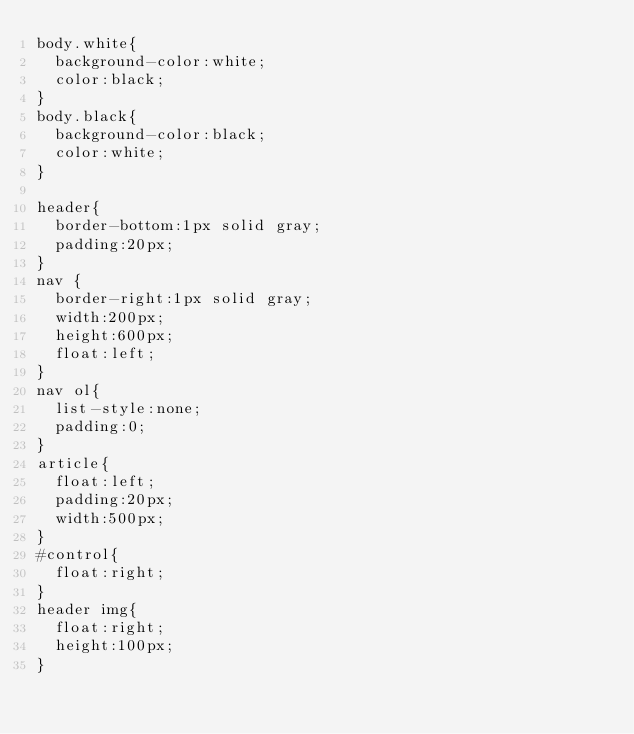<code> <loc_0><loc_0><loc_500><loc_500><_CSS_>body.white{
  background-color:white;
  color:black;
}
body.black{
  background-color:black;
  color:white;
}

header{
  border-bottom:1px solid gray;
  padding:20px;
}
nav {
  border-right:1px solid gray;
  width:200px;
  height:600px;
  float:left;
}
nav ol{
  list-style:none;
  padding:0;
}
article{
  float:left;
  padding:20px;
  width:500px;
}
#control{
  float:right;
}
header img{
  float:right;
  height:100px;
}
</code> 